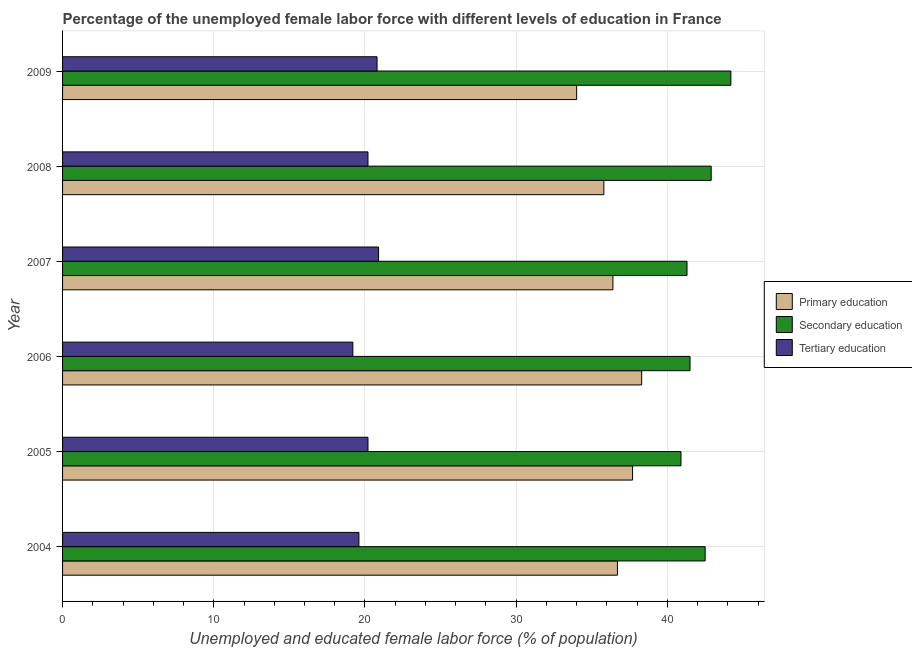How many different coloured bars are there?
Your answer should be very brief. 3. Are the number of bars on each tick of the Y-axis equal?
Ensure brevity in your answer.  Yes. What is the label of the 3rd group of bars from the top?
Ensure brevity in your answer.  2007. In how many cases, is the number of bars for a given year not equal to the number of legend labels?
Make the answer very short. 0. What is the percentage of female labor force who received secondary education in 2005?
Your answer should be very brief. 40.9. Across all years, what is the maximum percentage of female labor force who received tertiary education?
Make the answer very short. 20.9. Across all years, what is the minimum percentage of female labor force who received primary education?
Provide a short and direct response. 34. In which year was the percentage of female labor force who received secondary education minimum?
Provide a succinct answer. 2005. What is the total percentage of female labor force who received primary education in the graph?
Offer a terse response. 218.9. What is the difference between the percentage of female labor force who received secondary education in 2007 and that in 2008?
Your answer should be very brief. -1.6. What is the difference between the percentage of female labor force who received secondary education in 2009 and the percentage of female labor force who received tertiary education in 2005?
Make the answer very short. 24. What is the average percentage of female labor force who received secondary education per year?
Make the answer very short. 42.22. In the year 2004, what is the difference between the percentage of female labor force who received tertiary education and percentage of female labor force who received secondary education?
Offer a terse response. -22.9. What is the ratio of the percentage of female labor force who received tertiary education in 2004 to that in 2009?
Offer a terse response. 0.94. Is the percentage of female labor force who received tertiary education in 2006 less than that in 2007?
Your response must be concise. Yes. What is the difference between the highest and the second highest percentage of female labor force who received tertiary education?
Provide a succinct answer. 0.1. What is the difference between the highest and the lowest percentage of female labor force who received primary education?
Provide a succinct answer. 4.3. In how many years, is the percentage of female labor force who received tertiary education greater than the average percentage of female labor force who received tertiary education taken over all years?
Offer a terse response. 4. What does the 3rd bar from the bottom in 2009 represents?
Provide a succinct answer. Tertiary education. Is it the case that in every year, the sum of the percentage of female labor force who received primary education and percentage of female labor force who received secondary education is greater than the percentage of female labor force who received tertiary education?
Your answer should be compact. Yes. Are all the bars in the graph horizontal?
Keep it short and to the point. Yes. How many years are there in the graph?
Offer a very short reply. 6. What is the difference between two consecutive major ticks on the X-axis?
Provide a succinct answer. 10. Are the values on the major ticks of X-axis written in scientific E-notation?
Ensure brevity in your answer.  No. Does the graph contain any zero values?
Make the answer very short. No. Does the graph contain grids?
Your response must be concise. Yes. Where does the legend appear in the graph?
Keep it short and to the point. Center right. How many legend labels are there?
Your answer should be compact. 3. What is the title of the graph?
Give a very brief answer. Percentage of the unemployed female labor force with different levels of education in France. Does "Total employers" appear as one of the legend labels in the graph?
Provide a succinct answer. No. What is the label or title of the X-axis?
Give a very brief answer. Unemployed and educated female labor force (% of population). What is the Unemployed and educated female labor force (% of population) in Primary education in 2004?
Your answer should be compact. 36.7. What is the Unemployed and educated female labor force (% of population) in Secondary education in 2004?
Your answer should be compact. 42.5. What is the Unemployed and educated female labor force (% of population) in Tertiary education in 2004?
Provide a succinct answer. 19.6. What is the Unemployed and educated female labor force (% of population) of Primary education in 2005?
Your answer should be compact. 37.7. What is the Unemployed and educated female labor force (% of population) of Secondary education in 2005?
Make the answer very short. 40.9. What is the Unemployed and educated female labor force (% of population) of Tertiary education in 2005?
Offer a terse response. 20.2. What is the Unemployed and educated female labor force (% of population) of Primary education in 2006?
Offer a terse response. 38.3. What is the Unemployed and educated female labor force (% of population) in Secondary education in 2006?
Make the answer very short. 41.5. What is the Unemployed and educated female labor force (% of population) of Tertiary education in 2006?
Make the answer very short. 19.2. What is the Unemployed and educated female labor force (% of population) in Primary education in 2007?
Your answer should be compact. 36.4. What is the Unemployed and educated female labor force (% of population) in Secondary education in 2007?
Your answer should be very brief. 41.3. What is the Unemployed and educated female labor force (% of population) in Tertiary education in 2007?
Your answer should be compact. 20.9. What is the Unemployed and educated female labor force (% of population) in Primary education in 2008?
Provide a short and direct response. 35.8. What is the Unemployed and educated female labor force (% of population) of Secondary education in 2008?
Your answer should be compact. 42.9. What is the Unemployed and educated female labor force (% of population) in Tertiary education in 2008?
Provide a short and direct response. 20.2. What is the Unemployed and educated female labor force (% of population) of Primary education in 2009?
Make the answer very short. 34. What is the Unemployed and educated female labor force (% of population) in Secondary education in 2009?
Ensure brevity in your answer.  44.2. What is the Unemployed and educated female labor force (% of population) of Tertiary education in 2009?
Offer a terse response. 20.8. Across all years, what is the maximum Unemployed and educated female labor force (% of population) in Primary education?
Ensure brevity in your answer.  38.3. Across all years, what is the maximum Unemployed and educated female labor force (% of population) in Secondary education?
Your answer should be compact. 44.2. Across all years, what is the maximum Unemployed and educated female labor force (% of population) in Tertiary education?
Offer a terse response. 20.9. Across all years, what is the minimum Unemployed and educated female labor force (% of population) of Secondary education?
Ensure brevity in your answer.  40.9. Across all years, what is the minimum Unemployed and educated female labor force (% of population) in Tertiary education?
Offer a very short reply. 19.2. What is the total Unemployed and educated female labor force (% of population) in Primary education in the graph?
Provide a succinct answer. 218.9. What is the total Unemployed and educated female labor force (% of population) of Secondary education in the graph?
Provide a short and direct response. 253.3. What is the total Unemployed and educated female labor force (% of population) in Tertiary education in the graph?
Make the answer very short. 120.9. What is the difference between the Unemployed and educated female labor force (% of population) in Primary education in 2004 and that in 2005?
Provide a short and direct response. -1. What is the difference between the Unemployed and educated female labor force (% of population) of Secondary education in 2004 and that in 2006?
Ensure brevity in your answer.  1. What is the difference between the Unemployed and educated female labor force (% of population) of Tertiary education in 2004 and that in 2006?
Your response must be concise. 0.4. What is the difference between the Unemployed and educated female labor force (% of population) of Secondary education in 2004 and that in 2007?
Your answer should be very brief. 1.2. What is the difference between the Unemployed and educated female labor force (% of population) in Tertiary education in 2004 and that in 2007?
Keep it short and to the point. -1.3. What is the difference between the Unemployed and educated female labor force (% of population) in Secondary education in 2004 and that in 2008?
Offer a terse response. -0.4. What is the difference between the Unemployed and educated female labor force (% of population) in Tertiary education in 2004 and that in 2008?
Your answer should be very brief. -0.6. What is the difference between the Unemployed and educated female labor force (% of population) in Primary education in 2004 and that in 2009?
Offer a terse response. 2.7. What is the difference between the Unemployed and educated female labor force (% of population) of Tertiary education in 2004 and that in 2009?
Keep it short and to the point. -1.2. What is the difference between the Unemployed and educated female labor force (% of population) of Primary education in 2005 and that in 2006?
Provide a short and direct response. -0.6. What is the difference between the Unemployed and educated female labor force (% of population) in Tertiary education in 2005 and that in 2006?
Offer a terse response. 1. What is the difference between the Unemployed and educated female labor force (% of population) of Secondary education in 2005 and that in 2007?
Your response must be concise. -0.4. What is the difference between the Unemployed and educated female labor force (% of population) in Tertiary education in 2005 and that in 2007?
Offer a very short reply. -0.7. What is the difference between the Unemployed and educated female labor force (% of population) in Primary education in 2005 and that in 2008?
Provide a short and direct response. 1.9. What is the difference between the Unemployed and educated female labor force (% of population) of Tertiary education in 2005 and that in 2008?
Make the answer very short. 0. What is the difference between the Unemployed and educated female labor force (% of population) of Primary education in 2005 and that in 2009?
Offer a very short reply. 3.7. What is the difference between the Unemployed and educated female labor force (% of population) in Tertiary education in 2005 and that in 2009?
Offer a very short reply. -0.6. What is the difference between the Unemployed and educated female labor force (% of population) of Tertiary education in 2006 and that in 2007?
Provide a succinct answer. -1.7. What is the difference between the Unemployed and educated female labor force (% of population) of Tertiary education in 2006 and that in 2008?
Your response must be concise. -1. What is the difference between the Unemployed and educated female labor force (% of population) of Primary education in 2006 and that in 2009?
Your response must be concise. 4.3. What is the difference between the Unemployed and educated female labor force (% of population) in Secondary education in 2007 and that in 2008?
Keep it short and to the point. -1.6. What is the difference between the Unemployed and educated female labor force (% of population) in Tertiary education in 2007 and that in 2008?
Ensure brevity in your answer.  0.7. What is the difference between the Unemployed and educated female labor force (% of population) in Primary education in 2007 and that in 2009?
Your answer should be very brief. 2.4. What is the difference between the Unemployed and educated female labor force (% of population) in Tertiary education in 2007 and that in 2009?
Make the answer very short. 0.1. What is the difference between the Unemployed and educated female labor force (% of population) in Secondary education in 2008 and that in 2009?
Keep it short and to the point. -1.3. What is the difference between the Unemployed and educated female labor force (% of population) of Primary education in 2004 and the Unemployed and educated female labor force (% of population) of Secondary education in 2005?
Provide a short and direct response. -4.2. What is the difference between the Unemployed and educated female labor force (% of population) in Primary education in 2004 and the Unemployed and educated female labor force (% of population) in Tertiary education in 2005?
Offer a terse response. 16.5. What is the difference between the Unemployed and educated female labor force (% of population) of Secondary education in 2004 and the Unemployed and educated female labor force (% of population) of Tertiary education in 2005?
Provide a short and direct response. 22.3. What is the difference between the Unemployed and educated female labor force (% of population) in Primary education in 2004 and the Unemployed and educated female labor force (% of population) in Tertiary education in 2006?
Your answer should be compact. 17.5. What is the difference between the Unemployed and educated female labor force (% of population) of Secondary education in 2004 and the Unemployed and educated female labor force (% of population) of Tertiary education in 2006?
Give a very brief answer. 23.3. What is the difference between the Unemployed and educated female labor force (% of population) of Primary education in 2004 and the Unemployed and educated female labor force (% of population) of Secondary education in 2007?
Make the answer very short. -4.6. What is the difference between the Unemployed and educated female labor force (% of population) in Secondary education in 2004 and the Unemployed and educated female labor force (% of population) in Tertiary education in 2007?
Ensure brevity in your answer.  21.6. What is the difference between the Unemployed and educated female labor force (% of population) in Primary education in 2004 and the Unemployed and educated female labor force (% of population) in Secondary education in 2008?
Offer a very short reply. -6.2. What is the difference between the Unemployed and educated female labor force (% of population) in Secondary education in 2004 and the Unemployed and educated female labor force (% of population) in Tertiary education in 2008?
Offer a terse response. 22.3. What is the difference between the Unemployed and educated female labor force (% of population) of Secondary education in 2004 and the Unemployed and educated female labor force (% of population) of Tertiary education in 2009?
Offer a terse response. 21.7. What is the difference between the Unemployed and educated female labor force (% of population) of Primary education in 2005 and the Unemployed and educated female labor force (% of population) of Secondary education in 2006?
Give a very brief answer. -3.8. What is the difference between the Unemployed and educated female labor force (% of population) of Secondary education in 2005 and the Unemployed and educated female labor force (% of population) of Tertiary education in 2006?
Offer a terse response. 21.7. What is the difference between the Unemployed and educated female labor force (% of population) in Primary education in 2005 and the Unemployed and educated female labor force (% of population) in Secondary education in 2007?
Provide a short and direct response. -3.6. What is the difference between the Unemployed and educated female labor force (% of population) in Primary education in 2005 and the Unemployed and educated female labor force (% of population) in Tertiary education in 2007?
Your answer should be very brief. 16.8. What is the difference between the Unemployed and educated female labor force (% of population) in Secondary education in 2005 and the Unemployed and educated female labor force (% of population) in Tertiary education in 2007?
Offer a terse response. 20. What is the difference between the Unemployed and educated female labor force (% of population) in Secondary education in 2005 and the Unemployed and educated female labor force (% of population) in Tertiary education in 2008?
Offer a terse response. 20.7. What is the difference between the Unemployed and educated female labor force (% of population) of Primary education in 2005 and the Unemployed and educated female labor force (% of population) of Secondary education in 2009?
Your answer should be very brief. -6.5. What is the difference between the Unemployed and educated female labor force (% of population) in Primary education in 2005 and the Unemployed and educated female labor force (% of population) in Tertiary education in 2009?
Provide a succinct answer. 16.9. What is the difference between the Unemployed and educated female labor force (% of population) in Secondary education in 2005 and the Unemployed and educated female labor force (% of population) in Tertiary education in 2009?
Provide a succinct answer. 20.1. What is the difference between the Unemployed and educated female labor force (% of population) in Primary education in 2006 and the Unemployed and educated female labor force (% of population) in Tertiary education in 2007?
Your answer should be very brief. 17.4. What is the difference between the Unemployed and educated female labor force (% of population) in Secondary education in 2006 and the Unemployed and educated female labor force (% of population) in Tertiary education in 2007?
Give a very brief answer. 20.6. What is the difference between the Unemployed and educated female labor force (% of population) of Primary education in 2006 and the Unemployed and educated female labor force (% of population) of Secondary education in 2008?
Offer a very short reply. -4.6. What is the difference between the Unemployed and educated female labor force (% of population) of Secondary education in 2006 and the Unemployed and educated female labor force (% of population) of Tertiary education in 2008?
Your answer should be very brief. 21.3. What is the difference between the Unemployed and educated female labor force (% of population) of Primary education in 2006 and the Unemployed and educated female labor force (% of population) of Secondary education in 2009?
Offer a terse response. -5.9. What is the difference between the Unemployed and educated female labor force (% of population) in Secondary education in 2006 and the Unemployed and educated female labor force (% of population) in Tertiary education in 2009?
Offer a terse response. 20.7. What is the difference between the Unemployed and educated female labor force (% of population) of Secondary education in 2007 and the Unemployed and educated female labor force (% of population) of Tertiary education in 2008?
Your answer should be very brief. 21.1. What is the difference between the Unemployed and educated female labor force (% of population) in Primary education in 2007 and the Unemployed and educated female labor force (% of population) in Secondary education in 2009?
Keep it short and to the point. -7.8. What is the difference between the Unemployed and educated female labor force (% of population) in Primary education in 2007 and the Unemployed and educated female labor force (% of population) in Tertiary education in 2009?
Make the answer very short. 15.6. What is the difference between the Unemployed and educated female labor force (% of population) of Secondary education in 2007 and the Unemployed and educated female labor force (% of population) of Tertiary education in 2009?
Make the answer very short. 20.5. What is the difference between the Unemployed and educated female labor force (% of population) in Primary education in 2008 and the Unemployed and educated female labor force (% of population) in Secondary education in 2009?
Your answer should be very brief. -8.4. What is the difference between the Unemployed and educated female labor force (% of population) in Secondary education in 2008 and the Unemployed and educated female labor force (% of population) in Tertiary education in 2009?
Your answer should be compact. 22.1. What is the average Unemployed and educated female labor force (% of population) of Primary education per year?
Keep it short and to the point. 36.48. What is the average Unemployed and educated female labor force (% of population) of Secondary education per year?
Keep it short and to the point. 42.22. What is the average Unemployed and educated female labor force (% of population) in Tertiary education per year?
Your answer should be very brief. 20.15. In the year 2004, what is the difference between the Unemployed and educated female labor force (% of population) of Primary education and Unemployed and educated female labor force (% of population) of Tertiary education?
Offer a terse response. 17.1. In the year 2004, what is the difference between the Unemployed and educated female labor force (% of population) in Secondary education and Unemployed and educated female labor force (% of population) in Tertiary education?
Your response must be concise. 22.9. In the year 2005, what is the difference between the Unemployed and educated female labor force (% of population) of Secondary education and Unemployed and educated female labor force (% of population) of Tertiary education?
Provide a succinct answer. 20.7. In the year 2006, what is the difference between the Unemployed and educated female labor force (% of population) in Primary education and Unemployed and educated female labor force (% of population) in Tertiary education?
Your answer should be compact. 19.1. In the year 2006, what is the difference between the Unemployed and educated female labor force (% of population) in Secondary education and Unemployed and educated female labor force (% of population) in Tertiary education?
Make the answer very short. 22.3. In the year 2007, what is the difference between the Unemployed and educated female labor force (% of population) of Primary education and Unemployed and educated female labor force (% of population) of Secondary education?
Your answer should be compact. -4.9. In the year 2007, what is the difference between the Unemployed and educated female labor force (% of population) in Primary education and Unemployed and educated female labor force (% of population) in Tertiary education?
Give a very brief answer. 15.5. In the year 2007, what is the difference between the Unemployed and educated female labor force (% of population) of Secondary education and Unemployed and educated female labor force (% of population) of Tertiary education?
Ensure brevity in your answer.  20.4. In the year 2008, what is the difference between the Unemployed and educated female labor force (% of population) of Primary education and Unemployed and educated female labor force (% of population) of Secondary education?
Offer a very short reply. -7.1. In the year 2008, what is the difference between the Unemployed and educated female labor force (% of population) of Secondary education and Unemployed and educated female labor force (% of population) of Tertiary education?
Your response must be concise. 22.7. In the year 2009, what is the difference between the Unemployed and educated female labor force (% of population) in Primary education and Unemployed and educated female labor force (% of population) in Tertiary education?
Provide a succinct answer. 13.2. In the year 2009, what is the difference between the Unemployed and educated female labor force (% of population) of Secondary education and Unemployed and educated female labor force (% of population) of Tertiary education?
Provide a short and direct response. 23.4. What is the ratio of the Unemployed and educated female labor force (% of population) in Primary education in 2004 to that in 2005?
Provide a succinct answer. 0.97. What is the ratio of the Unemployed and educated female labor force (% of population) of Secondary education in 2004 to that in 2005?
Keep it short and to the point. 1.04. What is the ratio of the Unemployed and educated female labor force (% of population) of Tertiary education in 2004 to that in 2005?
Provide a short and direct response. 0.97. What is the ratio of the Unemployed and educated female labor force (% of population) of Primary education in 2004 to that in 2006?
Offer a terse response. 0.96. What is the ratio of the Unemployed and educated female labor force (% of population) in Secondary education in 2004 to that in 2006?
Ensure brevity in your answer.  1.02. What is the ratio of the Unemployed and educated female labor force (% of population) of Tertiary education in 2004 to that in 2006?
Offer a very short reply. 1.02. What is the ratio of the Unemployed and educated female labor force (% of population) of Primary education in 2004 to that in 2007?
Ensure brevity in your answer.  1.01. What is the ratio of the Unemployed and educated female labor force (% of population) in Secondary education in 2004 to that in 2007?
Provide a succinct answer. 1.03. What is the ratio of the Unemployed and educated female labor force (% of population) in Tertiary education in 2004 to that in 2007?
Ensure brevity in your answer.  0.94. What is the ratio of the Unemployed and educated female labor force (% of population) of Primary education in 2004 to that in 2008?
Your answer should be compact. 1.03. What is the ratio of the Unemployed and educated female labor force (% of population) in Tertiary education in 2004 to that in 2008?
Your response must be concise. 0.97. What is the ratio of the Unemployed and educated female labor force (% of population) of Primary education in 2004 to that in 2009?
Provide a succinct answer. 1.08. What is the ratio of the Unemployed and educated female labor force (% of population) of Secondary education in 2004 to that in 2009?
Your answer should be compact. 0.96. What is the ratio of the Unemployed and educated female labor force (% of population) of Tertiary education in 2004 to that in 2009?
Provide a short and direct response. 0.94. What is the ratio of the Unemployed and educated female labor force (% of population) of Primary education in 2005 to that in 2006?
Keep it short and to the point. 0.98. What is the ratio of the Unemployed and educated female labor force (% of population) of Secondary education in 2005 to that in 2006?
Provide a short and direct response. 0.99. What is the ratio of the Unemployed and educated female labor force (% of population) in Tertiary education in 2005 to that in 2006?
Offer a very short reply. 1.05. What is the ratio of the Unemployed and educated female labor force (% of population) of Primary education in 2005 to that in 2007?
Provide a succinct answer. 1.04. What is the ratio of the Unemployed and educated female labor force (% of population) in Secondary education in 2005 to that in 2007?
Offer a terse response. 0.99. What is the ratio of the Unemployed and educated female labor force (% of population) in Tertiary education in 2005 to that in 2007?
Offer a very short reply. 0.97. What is the ratio of the Unemployed and educated female labor force (% of population) of Primary education in 2005 to that in 2008?
Ensure brevity in your answer.  1.05. What is the ratio of the Unemployed and educated female labor force (% of population) in Secondary education in 2005 to that in 2008?
Make the answer very short. 0.95. What is the ratio of the Unemployed and educated female labor force (% of population) in Primary education in 2005 to that in 2009?
Make the answer very short. 1.11. What is the ratio of the Unemployed and educated female labor force (% of population) in Secondary education in 2005 to that in 2009?
Ensure brevity in your answer.  0.93. What is the ratio of the Unemployed and educated female labor force (% of population) in Tertiary education in 2005 to that in 2009?
Offer a very short reply. 0.97. What is the ratio of the Unemployed and educated female labor force (% of population) of Primary education in 2006 to that in 2007?
Keep it short and to the point. 1.05. What is the ratio of the Unemployed and educated female labor force (% of population) in Tertiary education in 2006 to that in 2007?
Offer a very short reply. 0.92. What is the ratio of the Unemployed and educated female labor force (% of population) of Primary education in 2006 to that in 2008?
Give a very brief answer. 1.07. What is the ratio of the Unemployed and educated female labor force (% of population) in Secondary education in 2006 to that in 2008?
Provide a succinct answer. 0.97. What is the ratio of the Unemployed and educated female labor force (% of population) in Tertiary education in 2006 to that in 2008?
Offer a very short reply. 0.95. What is the ratio of the Unemployed and educated female labor force (% of population) of Primary education in 2006 to that in 2009?
Your response must be concise. 1.13. What is the ratio of the Unemployed and educated female labor force (% of population) in Secondary education in 2006 to that in 2009?
Your response must be concise. 0.94. What is the ratio of the Unemployed and educated female labor force (% of population) in Tertiary education in 2006 to that in 2009?
Provide a short and direct response. 0.92. What is the ratio of the Unemployed and educated female labor force (% of population) in Primary education in 2007 to that in 2008?
Offer a terse response. 1.02. What is the ratio of the Unemployed and educated female labor force (% of population) of Secondary education in 2007 to that in 2008?
Ensure brevity in your answer.  0.96. What is the ratio of the Unemployed and educated female labor force (% of population) in Tertiary education in 2007 to that in 2008?
Give a very brief answer. 1.03. What is the ratio of the Unemployed and educated female labor force (% of population) in Primary education in 2007 to that in 2009?
Provide a short and direct response. 1.07. What is the ratio of the Unemployed and educated female labor force (% of population) of Secondary education in 2007 to that in 2009?
Keep it short and to the point. 0.93. What is the ratio of the Unemployed and educated female labor force (% of population) of Primary education in 2008 to that in 2009?
Offer a very short reply. 1.05. What is the ratio of the Unemployed and educated female labor force (% of population) in Secondary education in 2008 to that in 2009?
Keep it short and to the point. 0.97. What is the ratio of the Unemployed and educated female labor force (% of population) of Tertiary education in 2008 to that in 2009?
Give a very brief answer. 0.97. What is the difference between the highest and the lowest Unemployed and educated female labor force (% of population) in Secondary education?
Ensure brevity in your answer.  3.3. What is the difference between the highest and the lowest Unemployed and educated female labor force (% of population) of Tertiary education?
Provide a succinct answer. 1.7. 